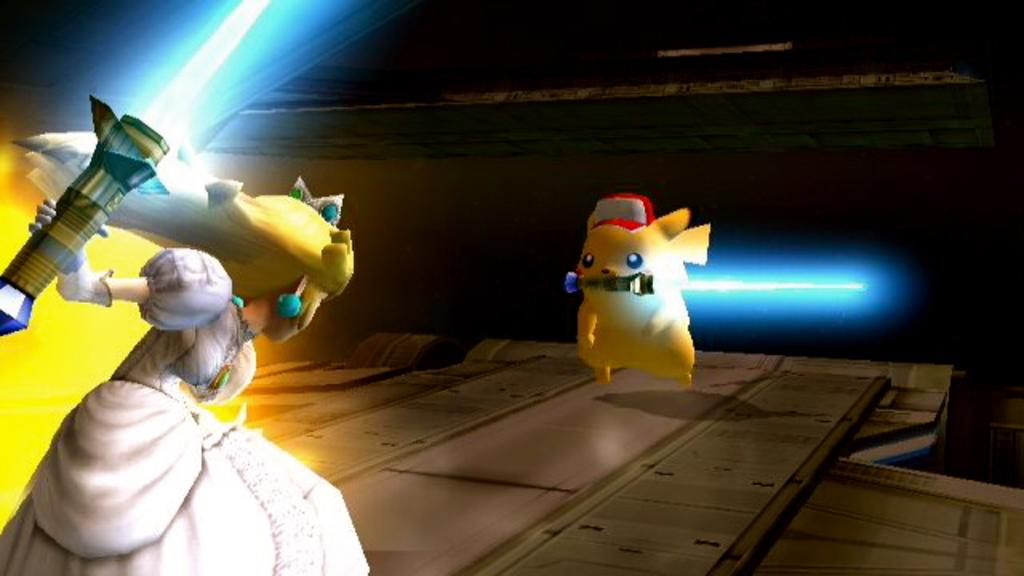What type of image is depicted in the picture? The image contains an animated picture of an animal. Can you describe the characters in the animated picture? There is a lady and an animal in the animated picture. What are the characters holding in the image? The animal and the lady are holding objects. What is the color of the background in the image? The background of the image is dark. What type of light can be seen in the image? There is no light source visible in the image, as the background is dark. How does the lady express her feelings of shame in the image? There is no indication of shame or any emotions in the image; it only shows an animated picture of an animal and a lady holding objects. 